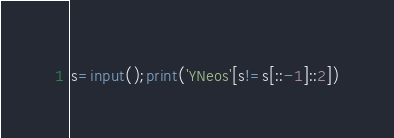<code> <loc_0><loc_0><loc_500><loc_500><_Python_>s=input();print('YNeos'[s!=s[::-1]::2])</code> 